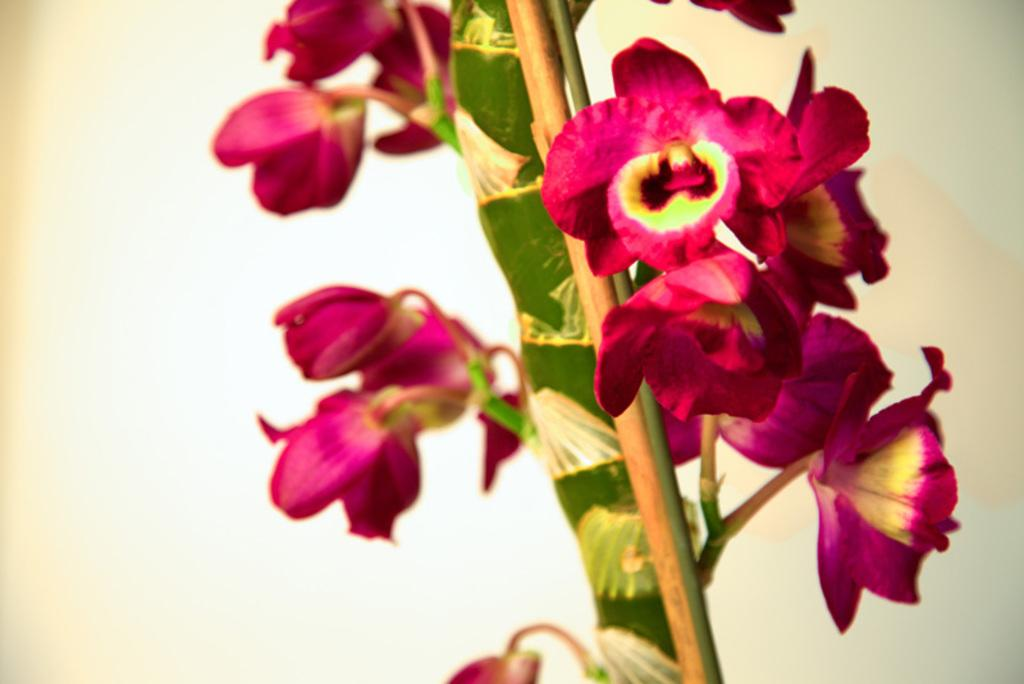What type of plant can be seen in the image? There is a flower plant in the image. What does the flower plant symbolize in terms of peace and digestion? The image does not provide any information about the symbolism or meaning of the flower plant, nor does it mention anything related to peace or digestion. 